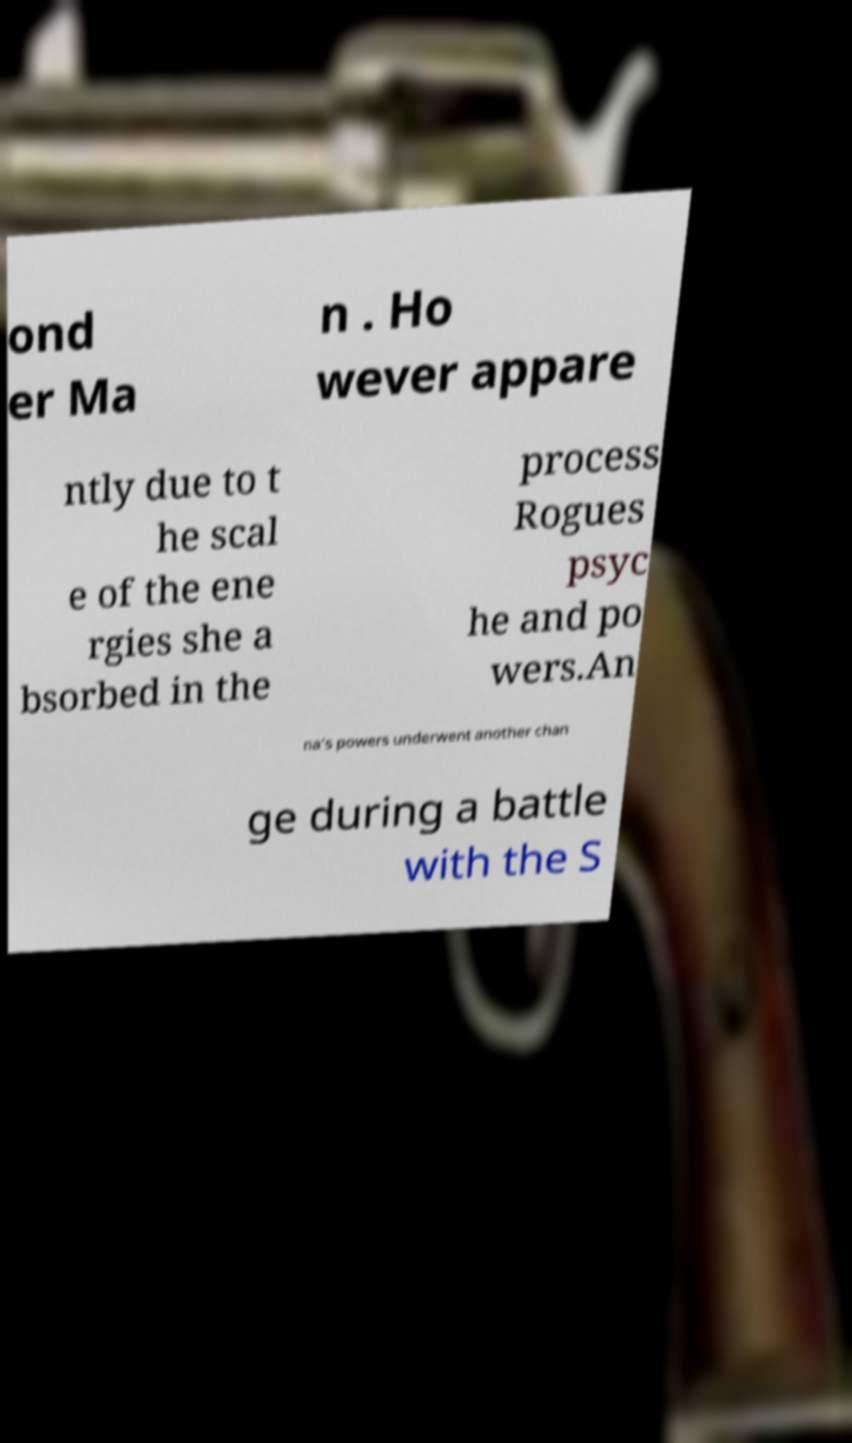Can you read and provide the text displayed in the image?This photo seems to have some interesting text. Can you extract and type it out for me? ond er Ma n . Ho wever appare ntly due to t he scal e of the ene rgies she a bsorbed in the process Rogues psyc he and po wers.An na's powers underwent another chan ge during a battle with the S 